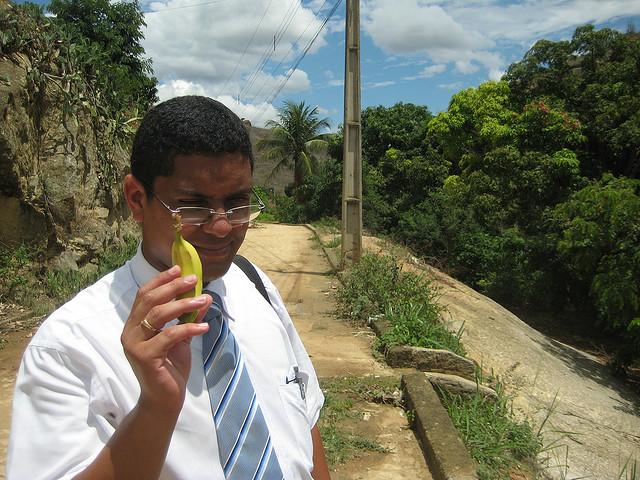Does this person have 20/20 vision?
Concise answer only. No. Is he holding fruit?
Be succinct. Yes. Does it appear to be rainy?
Give a very brief answer. No. 